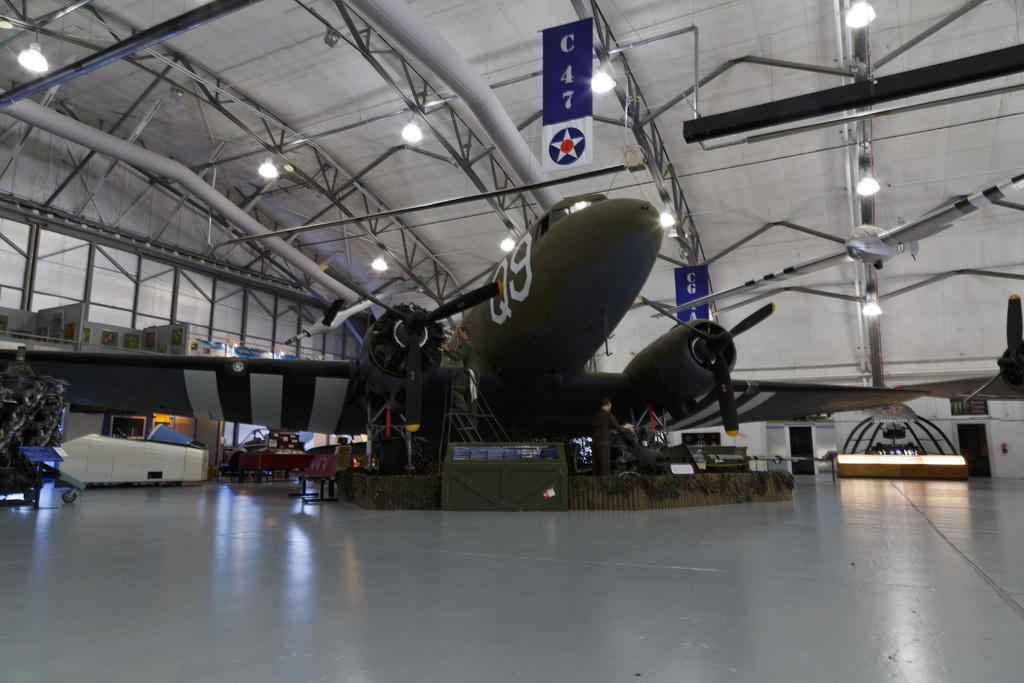<image>
Offer a succinct explanation of the picture presented. An airplane with Q9 on its side sits in a hangar. 